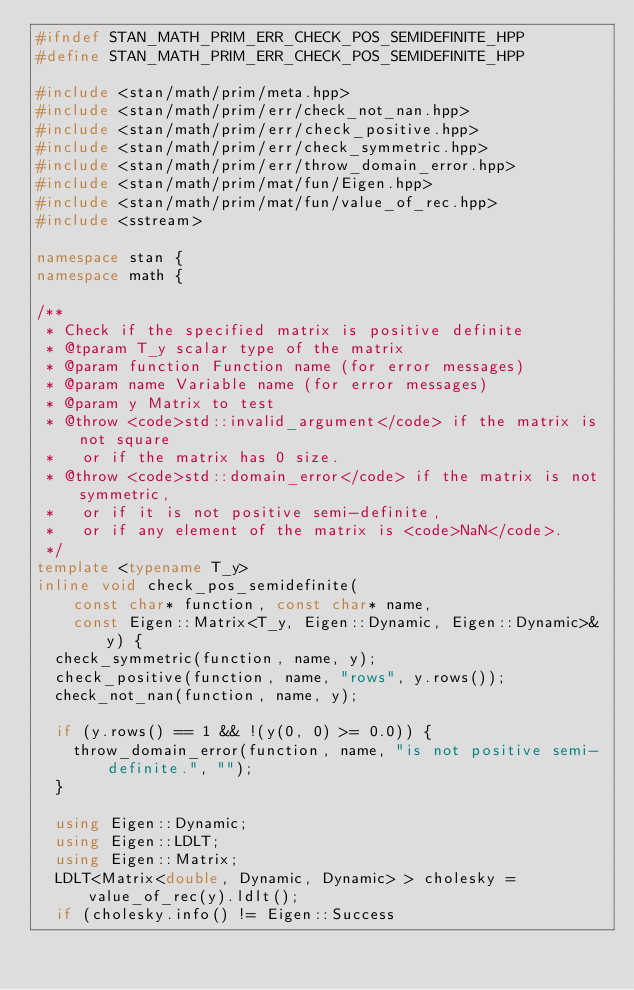<code> <loc_0><loc_0><loc_500><loc_500><_C++_>#ifndef STAN_MATH_PRIM_ERR_CHECK_POS_SEMIDEFINITE_HPP
#define STAN_MATH_PRIM_ERR_CHECK_POS_SEMIDEFINITE_HPP

#include <stan/math/prim/meta.hpp>
#include <stan/math/prim/err/check_not_nan.hpp>
#include <stan/math/prim/err/check_positive.hpp>
#include <stan/math/prim/err/check_symmetric.hpp>
#include <stan/math/prim/err/throw_domain_error.hpp>
#include <stan/math/prim/mat/fun/Eigen.hpp>
#include <stan/math/prim/mat/fun/value_of_rec.hpp>
#include <sstream>

namespace stan {
namespace math {

/**
 * Check if the specified matrix is positive definite
 * @tparam T_y scalar type of the matrix
 * @param function Function name (for error messages)
 * @param name Variable name (for error messages)
 * @param y Matrix to test
 * @throw <code>std::invalid_argument</code> if the matrix is not square
 *   or if the matrix has 0 size.
 * @throw <code>std::domain_error</code> if the matrix is not symmetric,
 *   or if it is not positive semi-definite,
 *   or if any element of the matrix is <code>NaN</code>.
 */
template <typename T_y>
inline void check_pos_semidefinite(
    const char* function, const char* name,
    const Eigen::Matrix<T_y, Eigen::Dynamic, Eigen::Dynamic>& y) {
  check_symmetric(function, name, y);
  check_positive(function, name, "rows", y.rows());
  check_not_nan(function, name, y);

  if (y.rows() == 1 && !(y(0, 0) >= 0.0)) {
    throw_domain_error(function, name, "is not positive semi-definite.", "");
  }

  using Eigen::Dynamic;
  using Eigen::LDLT;
  using Eigen::Matrix;
  LDLT<Matrix<double, Dynamic, Dynamic> > cholesky = value_of_rec(y).ldlt();
  if (cholesky.info() != Eigen::Success</code> 